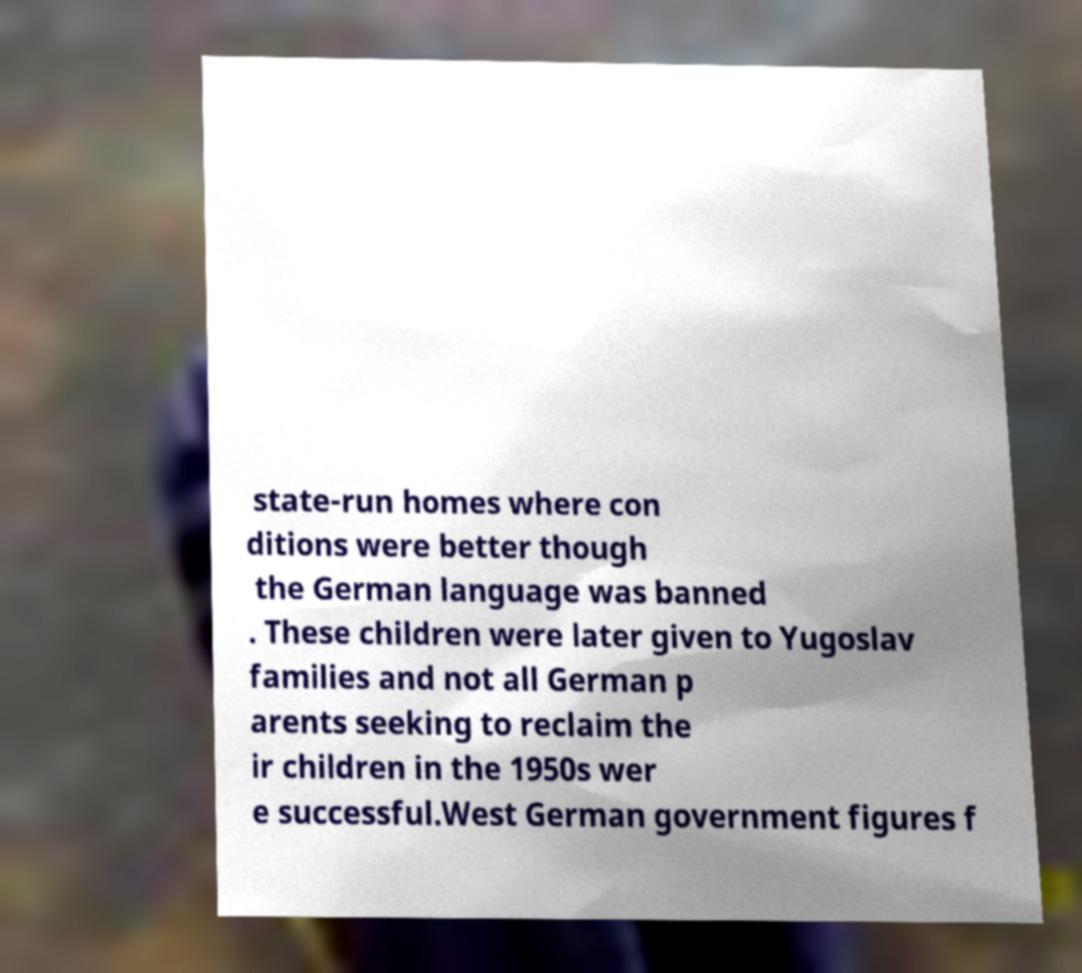Can you read and provide the text displayed in the image?This photo seems to have some interesting text. Can you extract and type it out for me? state-run homes where con ditions were better though the German language was banned . These children were later given to Yugoslav families and not all German p arents seeking to reclaim the ir children in the 1950s wer e successful.West German government figures f 